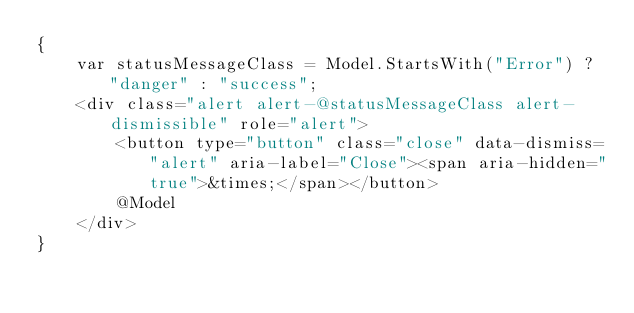Convert code to text. <code><loc_0><loc_0><loc_500><loc_500><_C#_>{
    var statusMessageClass = Model.StartsWith("Error") ? "danger" : "success";
    <div class="alert alert-@statusMessageClass alert-dismissible" role="alert">
        <button type="button" class="close" data-dismiss="alert" aria-label="Close"><span aria-hidden="true">&times;</span></button>
        @Model
    </div>
}
</code> 